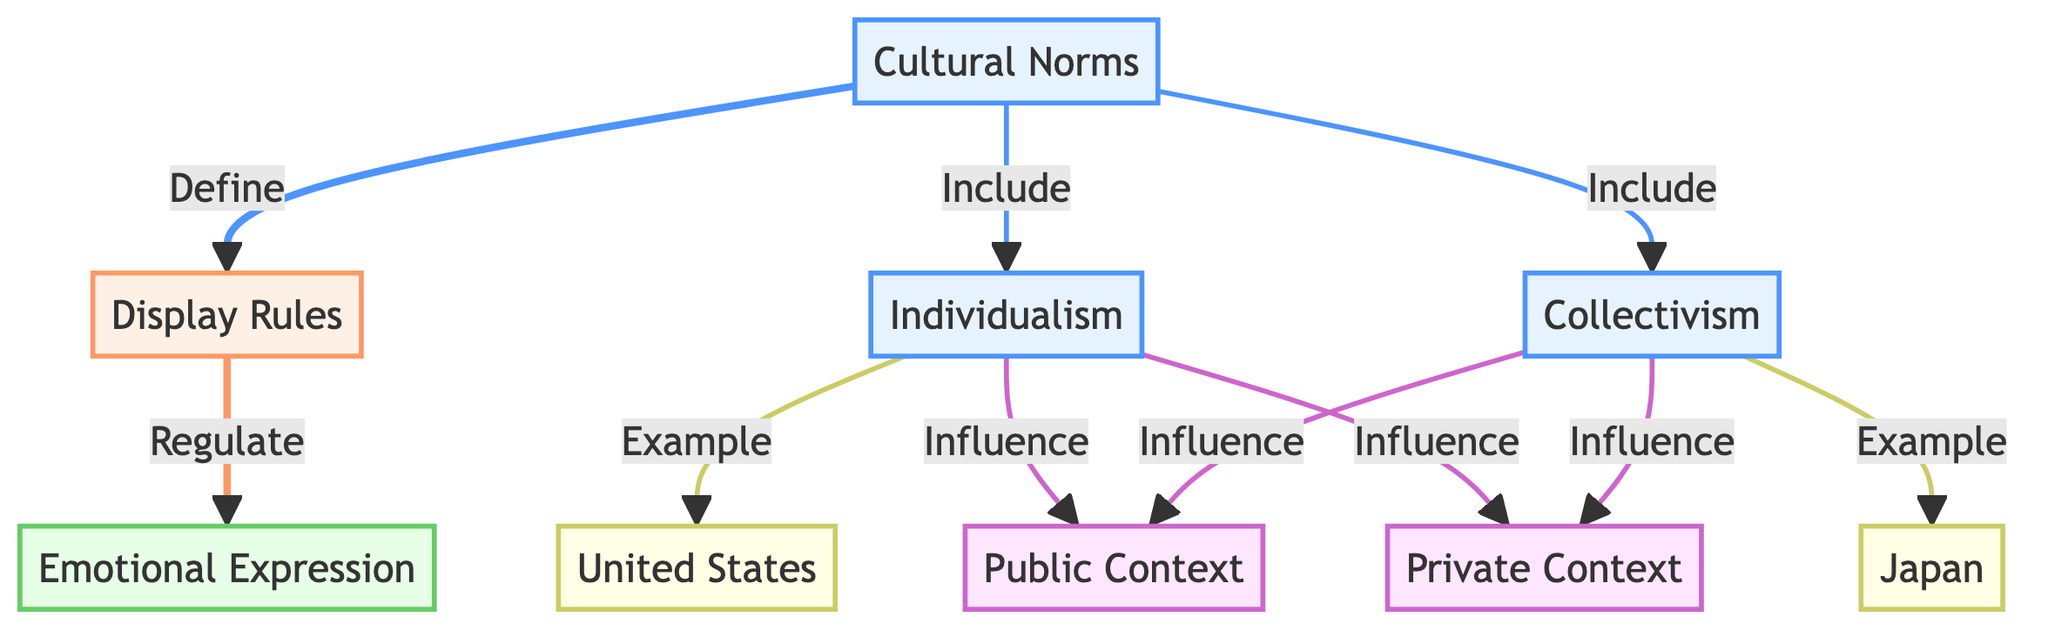What are the two types of cultural norms represented? The diagram includes two types of cultural norms: Individualism and Collectivism, shown as separate nodes branching from Cultural Norms.
Answer: Individualism and Collectivism How many emotional expressions are regulated by display rules? The diagram indicates that display rules regulate emotional expressions, but does not specify a number. However, 'Emotional Expression' is listed as a single node, implying it is a singular category influenced by display rules.
Answer: 1 Which country is an example of individualism? The diagram explicitly shows that the United States is an example of individualism, as it is linked to the Individualism node.
Answer: United States What influences the public context for emotional expression? Both Individualism and Collectivism influence the public context. The diagram shows arrows from both cultural norms leading to the 'Public Context' node.
Answer: Individualism and Collectivism Which context is influenced by collectivism? The diagram indicates that collectivism influences both public and private contexts, but to answer specifically for the question, the private context is also influenced as shown in the connections.
Answer: Private Context How many edges lead from cultural norms to display rules? There is one edge that links cultural norms directly to display rules, showing that cultural norms define display rules.
Answer: 1 What does “regulate” refer to in the context of the diagram? In the diagram, it refers to the relationship where display rules, which are influenced by cultural norms, regulate emotional expressions. Thus, it indicates how emotions are presented based on cultural context.
Answer: Display Rules What is the role of Cultural Norms in the diagram? Cultural Norms serve as the foundational concept that both defines display rules and includes specific types such as Individualism and Collectivism, indicating their overarching influence on emotional expression.
Answer: Define Display Rules Which country is associated with collectivism? According to the diagram, Japan is the country linked to the collectivism node, demonstrating the example of how collectivist norms manifest culturally.
Answer: Japan 